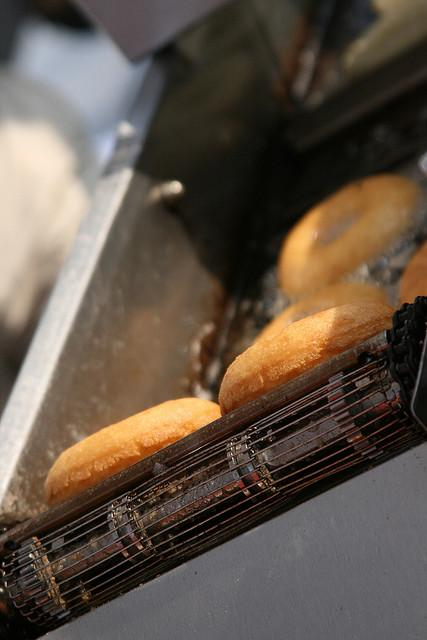What step of donut creation is this scene at? Please explain your reasoning. frying. Donuts are on a metal surface in front of others that are sitting in oil. 